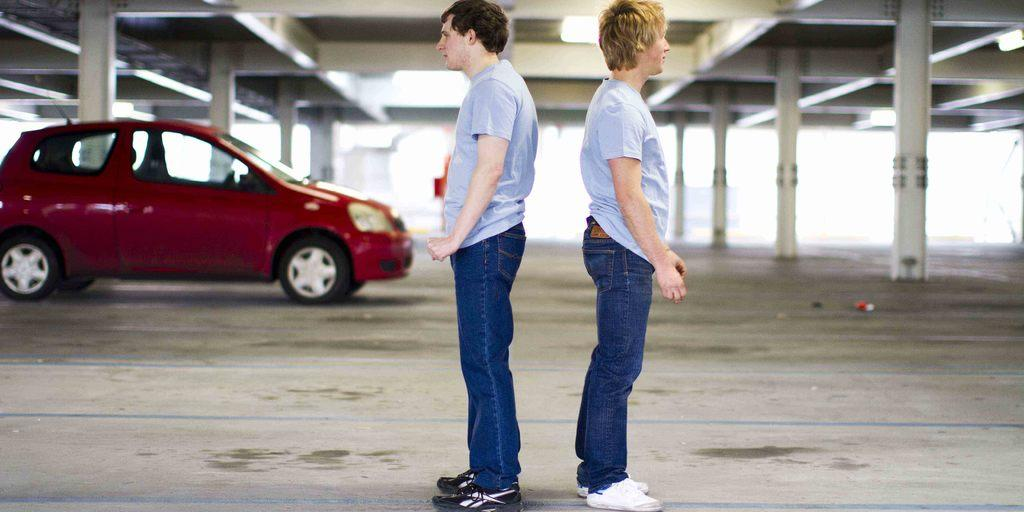What can be seen in the image regarding human figures? There are men standing in the image. Where are the men positioned in the image? The men are standing on the floor. What type of vehicle is present in the image? There is a motor vehicle in the image. What architectural features can be observed in the image? There are pillars and a roof in the image. What color is the scarf worn by the man in the image? There is no scarf present in the image, so it is not possible to determine its color. 